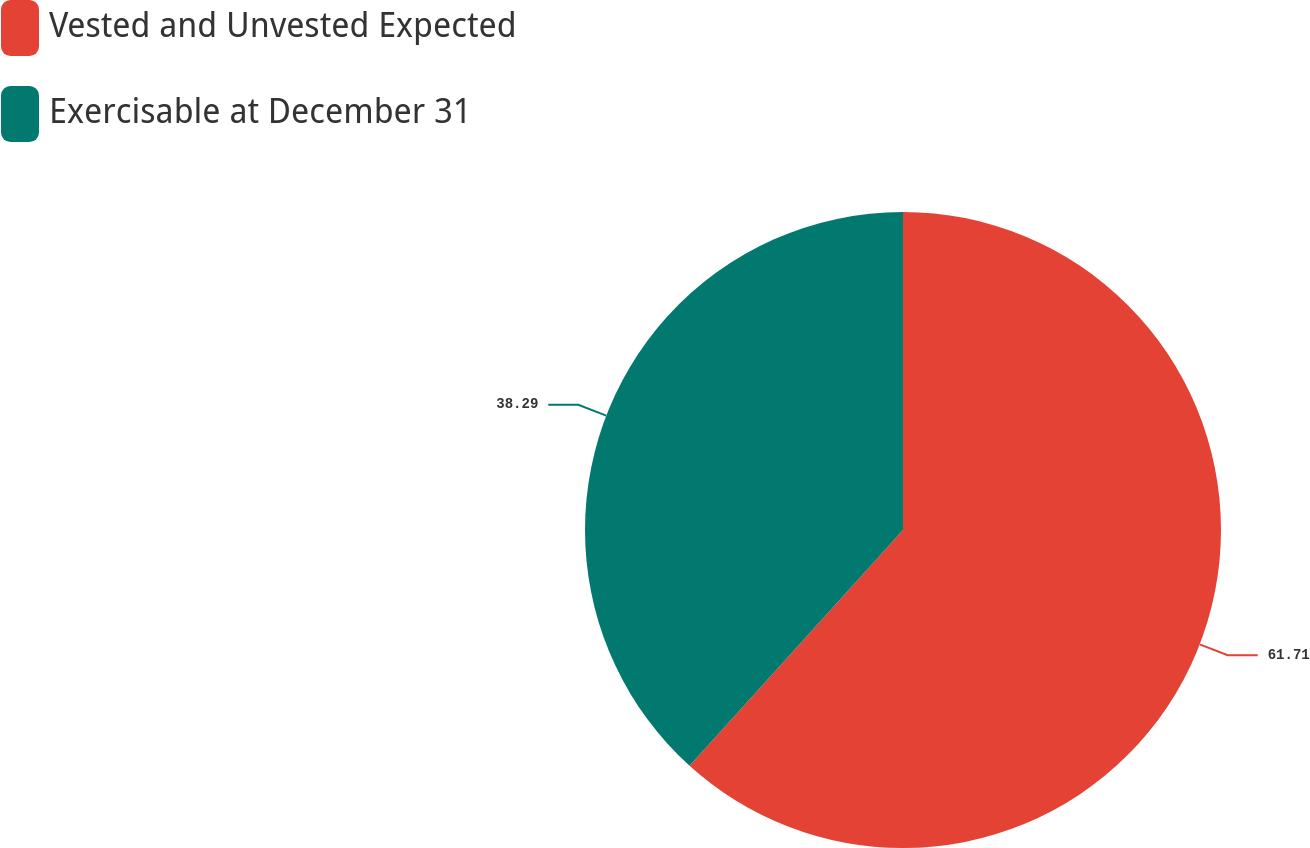Convert chart. <chart><loc_0><loc_0><loc_500><loc_500><pie_chart><fcel>Vested and Unvested Expected<fcel>Exercisable at December 31<nl><fcel>61.71%<fcel>38.29%<nl></chart> 